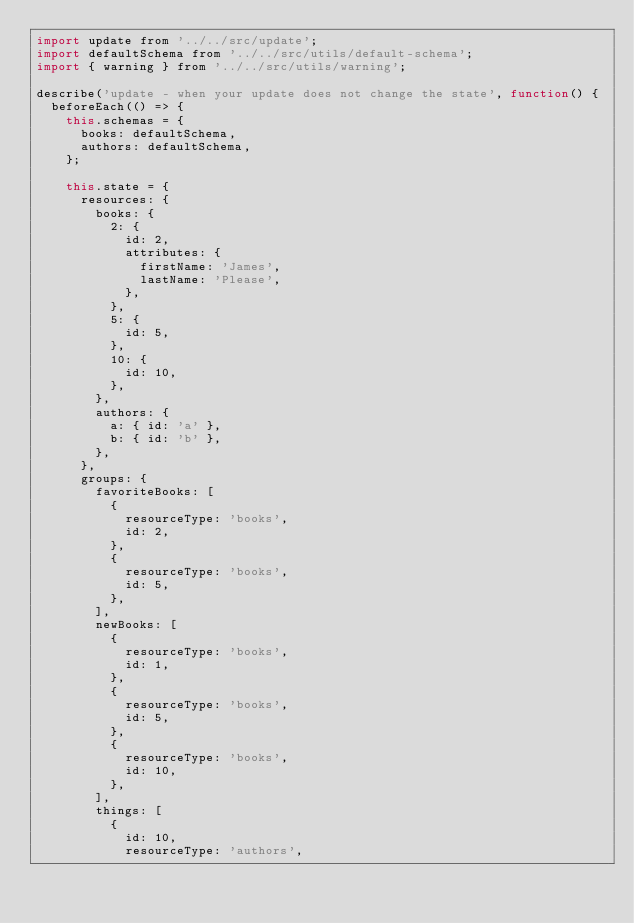Convert code to text. <code><loc_0><loc_0><loc_500><loc_500><_JavaScript_>import update from '../../src/update';
import defaultSchema from '../../src/utils/default-schema';
import { warning } from '../../src/utils/warning';

describe('update - when your update does not change the state', function() {
  beforeEach(() => {
    this.schemas = {
      books: defaultSchema,
      authors: defaultSchema,
    };

    this.state = {
      resources: {
        books: {
          2: {
            id: 2,
            attributes: {
              firstName: 'James',
              lastName: 'Please',
            },
          },
          5: {
            id: 5,
          },
          10: {
            id: 10,
          },
        },
        authors: {
          a: { id: 'a' },
          b: { id: 'b' },
        },
      },
      groups: {
        favoriteBooks: [
          {
            resourceType: 'books',
            id: 2,
          },
          {
            resourceType: 'books',
            id: 5,
          },
        ],
        newBooks: [
          {
            resourceType: 'books',
            id: 1,
          },
          {
            resourceType: 'books',
            id: 5,
          },
          {
            resourceType: 'books',
            id: 10,
          },
        ],
        things: [
          {
            id: 10,
            resourceType: 'authors',</code> 